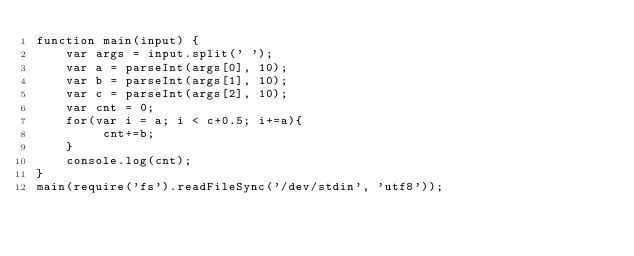Convert code to text. <code><loc_0><loc_0><loc_500><loc_500><_JavaScript_>function main(input) {
    var args = input.split(' ');
    var a = parseInt(args[0], 10);
    var b = parseInt(args[1], 10);
    var c = parseInt(args[2], 10);
    var cnt = 0;
    for(var i = a; i < c+0.5; i+=a){
         cnt+=b;
    }
    console.log(cnt);
}
main(require('fs').readFileSync('/dev/stdin', 'utf8'));</code> 